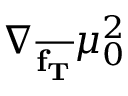<formula> <loc_0><loc_0><loc_500><loc_500>\nabla _ { \overline { { f _ { T } } } } \mu _ { 0 } ^ { 2 }</formula> 